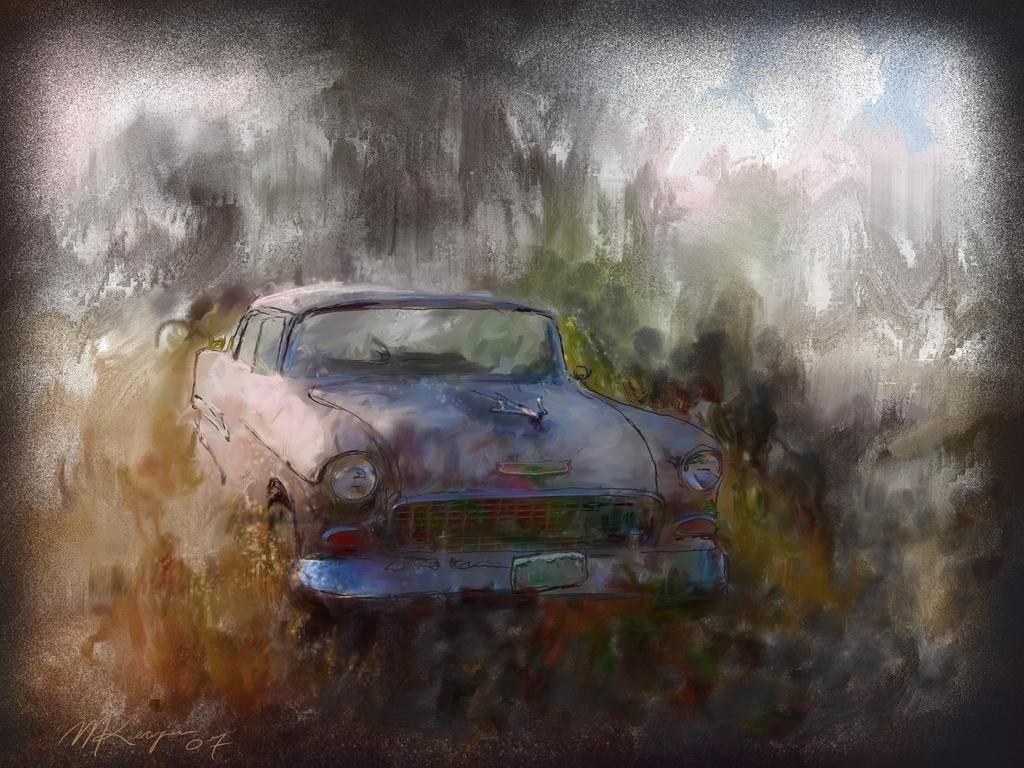What is the main subject of the painting in the image? The painting depicts a car. What other elements are included in the painting? The painting includes trees and the sky. What type of toothbrush is used to clean the car in the painting? There is no toothbrush present in the painting; it is a depiction of a car, trees, and the sky. 